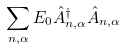<formula> <loc_0><loc_0><loc_500><loc_500>\sum _ { n , \alpha } E _ { 0 } \hat { A } _ { n , \alpha } ^ { \dagger } \hat { A } _ { n , \alpha }</formula> 